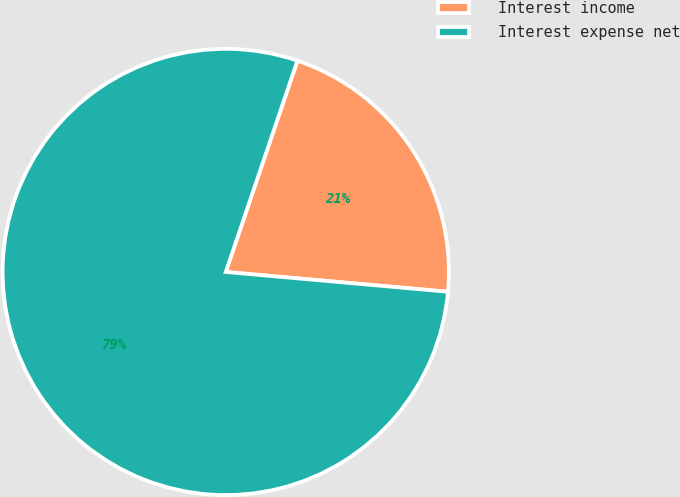<chart> <loc_0><loc_0><loc_500><loc_500><pie_chart><fcel>Interest income<fcel>Interest expense net<nl><fcel>21.21%<fcel>78.79%<nl></chart> 